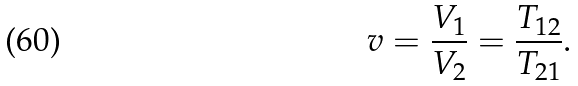Convert formula to latex. <formula><loc_0><loc_0><loc_500><loc_500>v = \frac { V _ { 1 } } { V _ { 2 } } = \frac { T _ { 1 2 } } { T _ { 2 1 } } .</formula> 